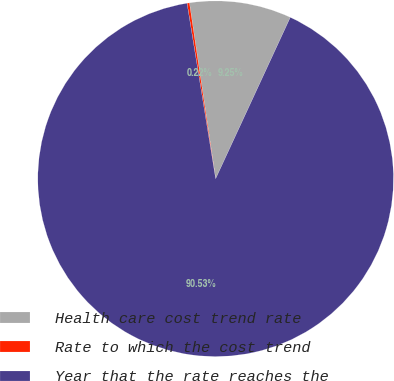<chart> <loc_0><loc_0><loc_500><loc_500><pie_chart><fcel>Health care cost trend rate<fcel>Rate to which the cost trend<fcel>Year that the rate reaches the<nl><fcel>9.25%<fcel>0.22%<fcel>90.52%<nl></chart> 